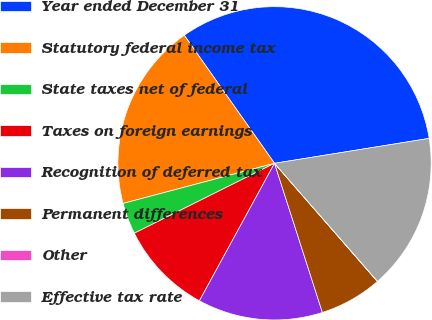Convert chart. <chart><loc_0><loc_0><loc_500><loc_500><pie_chart><fcel>Year ended December 31<fcel>Statutory federal income tax<fcel>State taxes net of federal<fcel>Taxes on foreign earnings<fcel>Recognition of deferred tax<fcel>Permanent differences<fcel>Other<fcel>Effective tax rate<nl><fcel>32.23%<fcel>19.35%<fcel>3.24%<fcel>9.68%<fcel>12.9%<fcel>6.46%<fcel>0.02%<fcel>16.12%<nl></chart> 